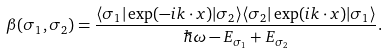Convert formula to latex. <formula><loc_0><loc_0><loc_500><loc_500>\beta ( \sigma _ { 1 } , \sigma _ { 2 } ) = \frac { \langle \sigma _ { 1 } | \exp ( - i k \cdot x ) | \sigma _ { 2 } \rangle \langle \sigma _ { 2 } | \exp ( i k \cdot x ) | \sigma _ { 1 } \rangle } { \hbar { \omega } - E _ { \sigma _ { 1 } } + E _ { \sigma _ { 2 } } } .</formula> 